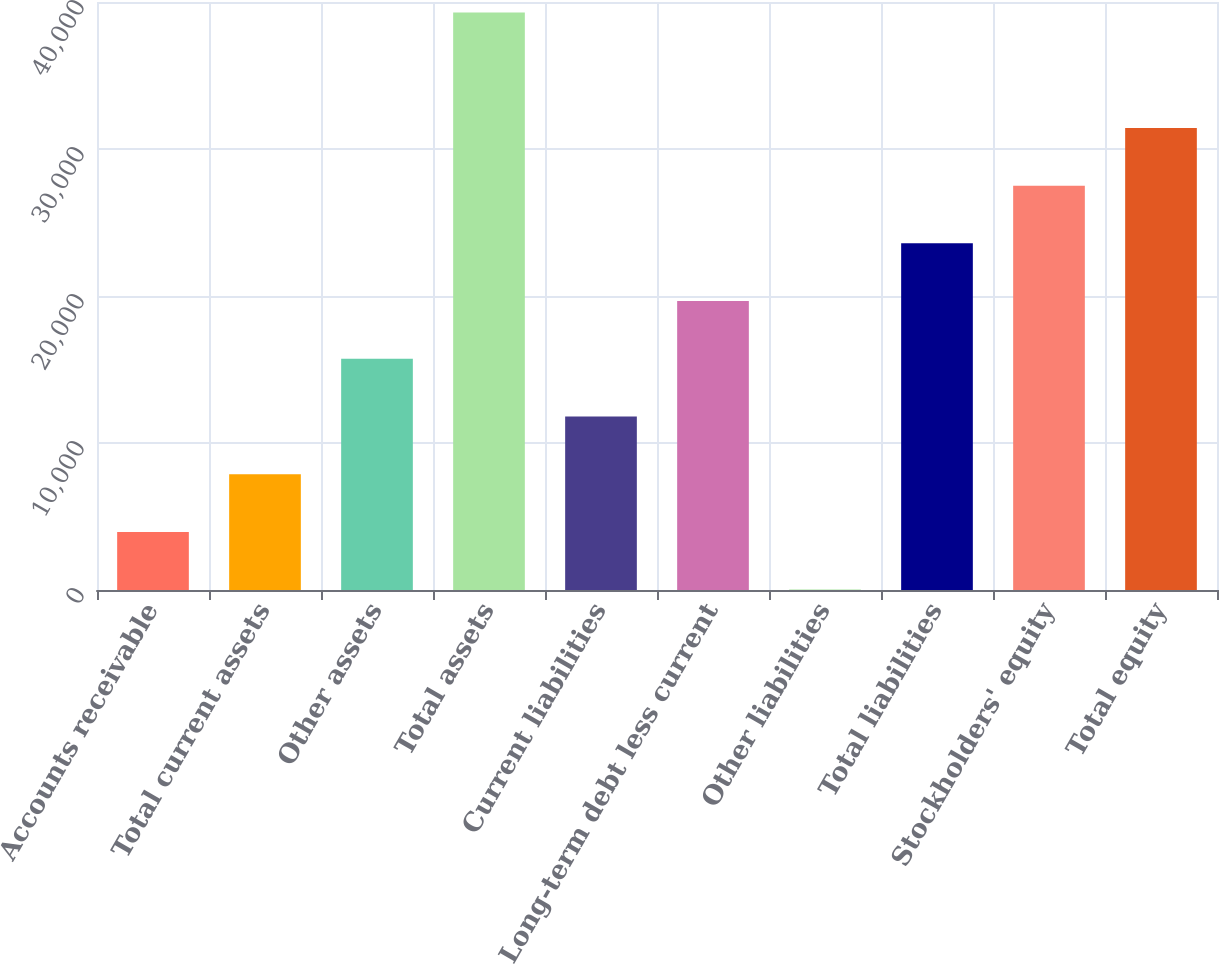Convert chart to OTSL. <chart><loc_0><loc_0><loc_500><loc_500><bar_chart><fcel>Accounts receivable<fcel>Total current assets<fcel>Other assets<fcel>Total assets<fcel>Current liabilities<fcel>Long-term debt less current<fcel>Other liabilities<fcel>Total liabilities<fcel>Stockholders' equity<fcel>Total equity<nl><fcel>3951.8<fcel>7877.6<fcel>15729.2<fcel>39284<fcel>11803.4<fcel>19655<fcel>26<fcel>23580.8<fcel>27506.6<fcel>31432.4<nl></chart> 